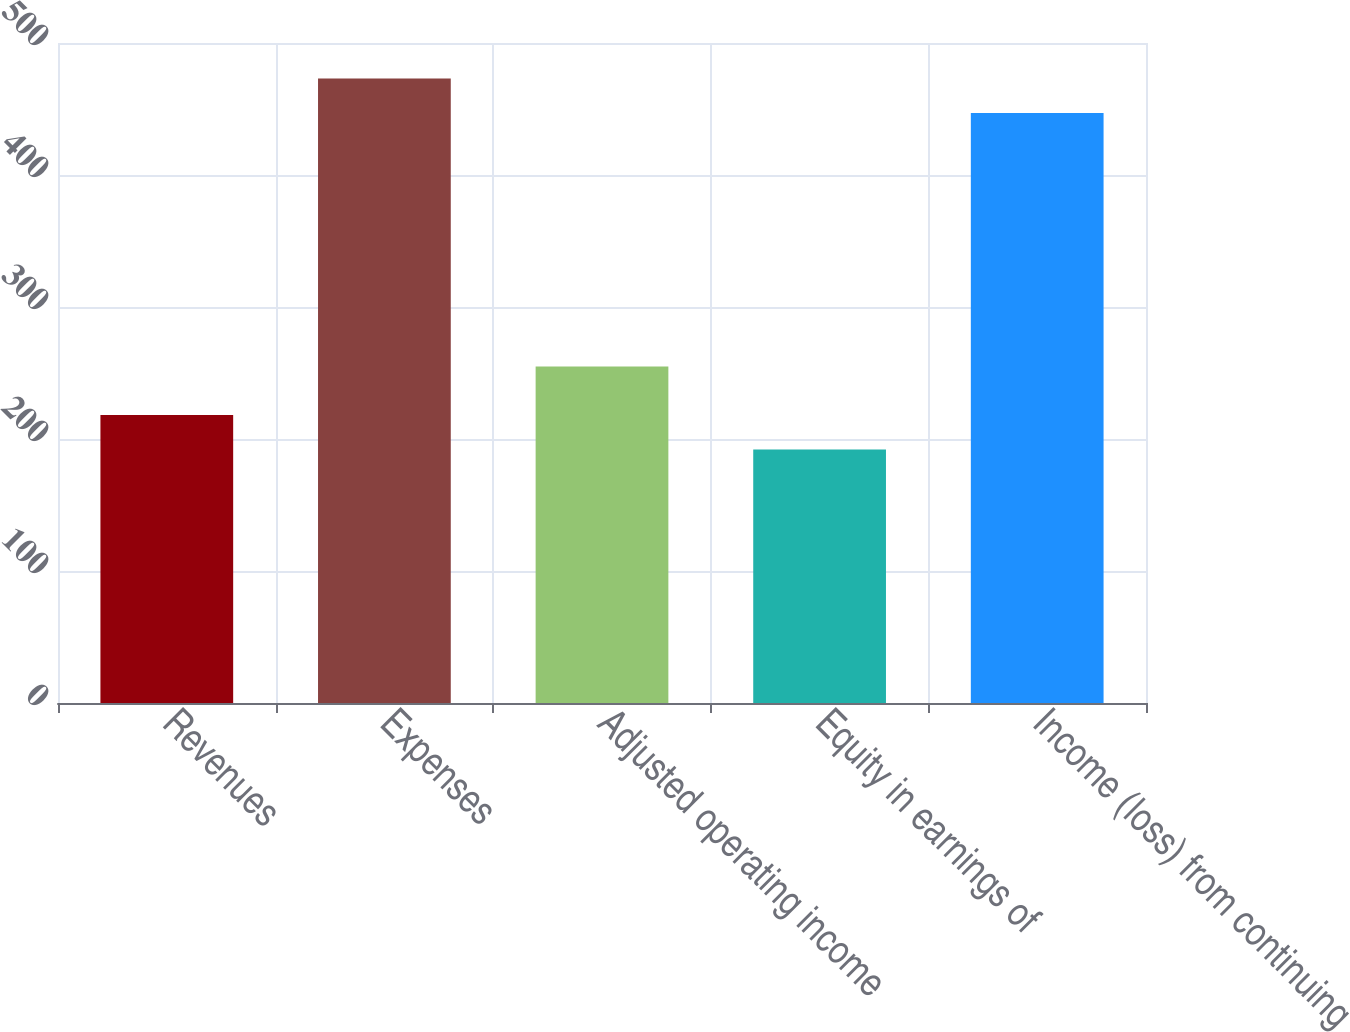Convert chart to OTSL. <chart><loc_0><loc_0><loc_500><loc_500><bar_chart><fcel>Revenues<fcel>Expenses<fcel>Adjusted operating income<fcel>Equity in earnings of<fcel>Income (loss) from continuing<nl><fcel>218.2<fcel>473.2<fcel>255<fcel>192<fcel>447<nl></chart> 